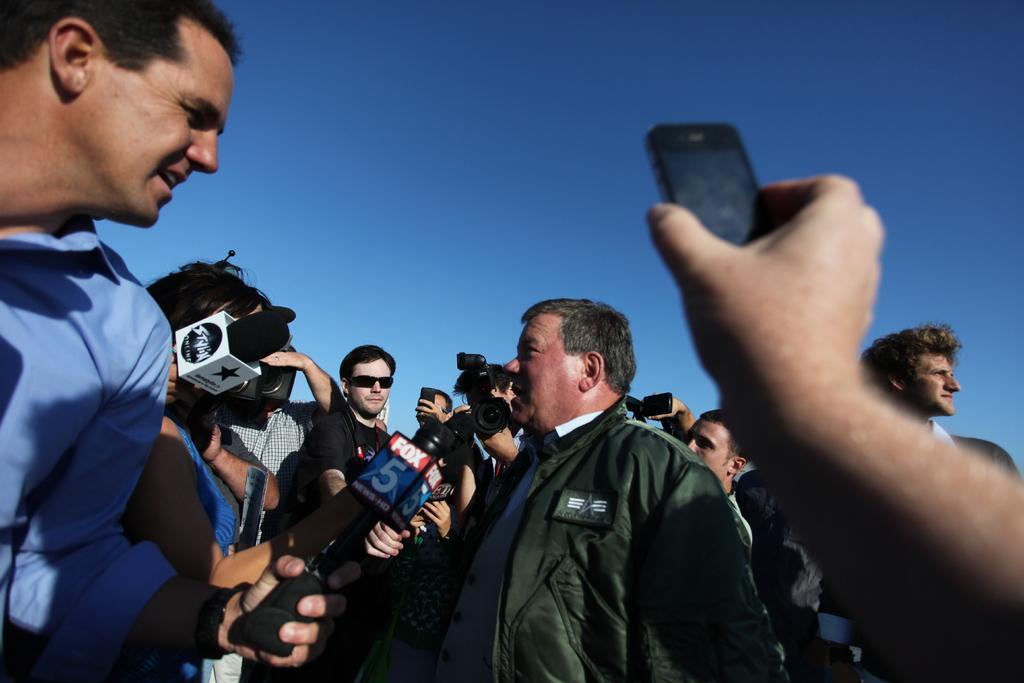How would you summarize this image in a sentence or two? A person is standing wearing jacket and talking. In front of him many person are standing holding mics. In the center a person is wearing goggles. Above there is sky. In the right persons hand is visible holding a recorder. 